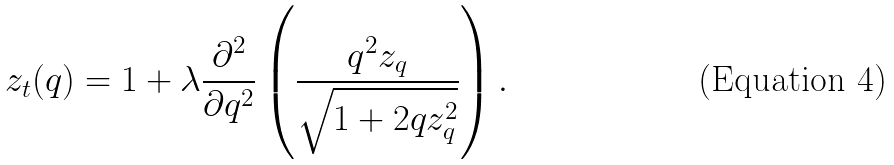<formula> <loc_0><loc_0><loc_500><loc_500>z _ { t } ( q ) = 1 + \lambda \frac { \partial ^ { 2 } } { \partial q ^ { 2 } } \left ( \frac { q ^ { 2 } z _ { q } } { \sqrt { 1 + 2 q z _ { q } ^ { 2 } } } \right ) .</formula> 